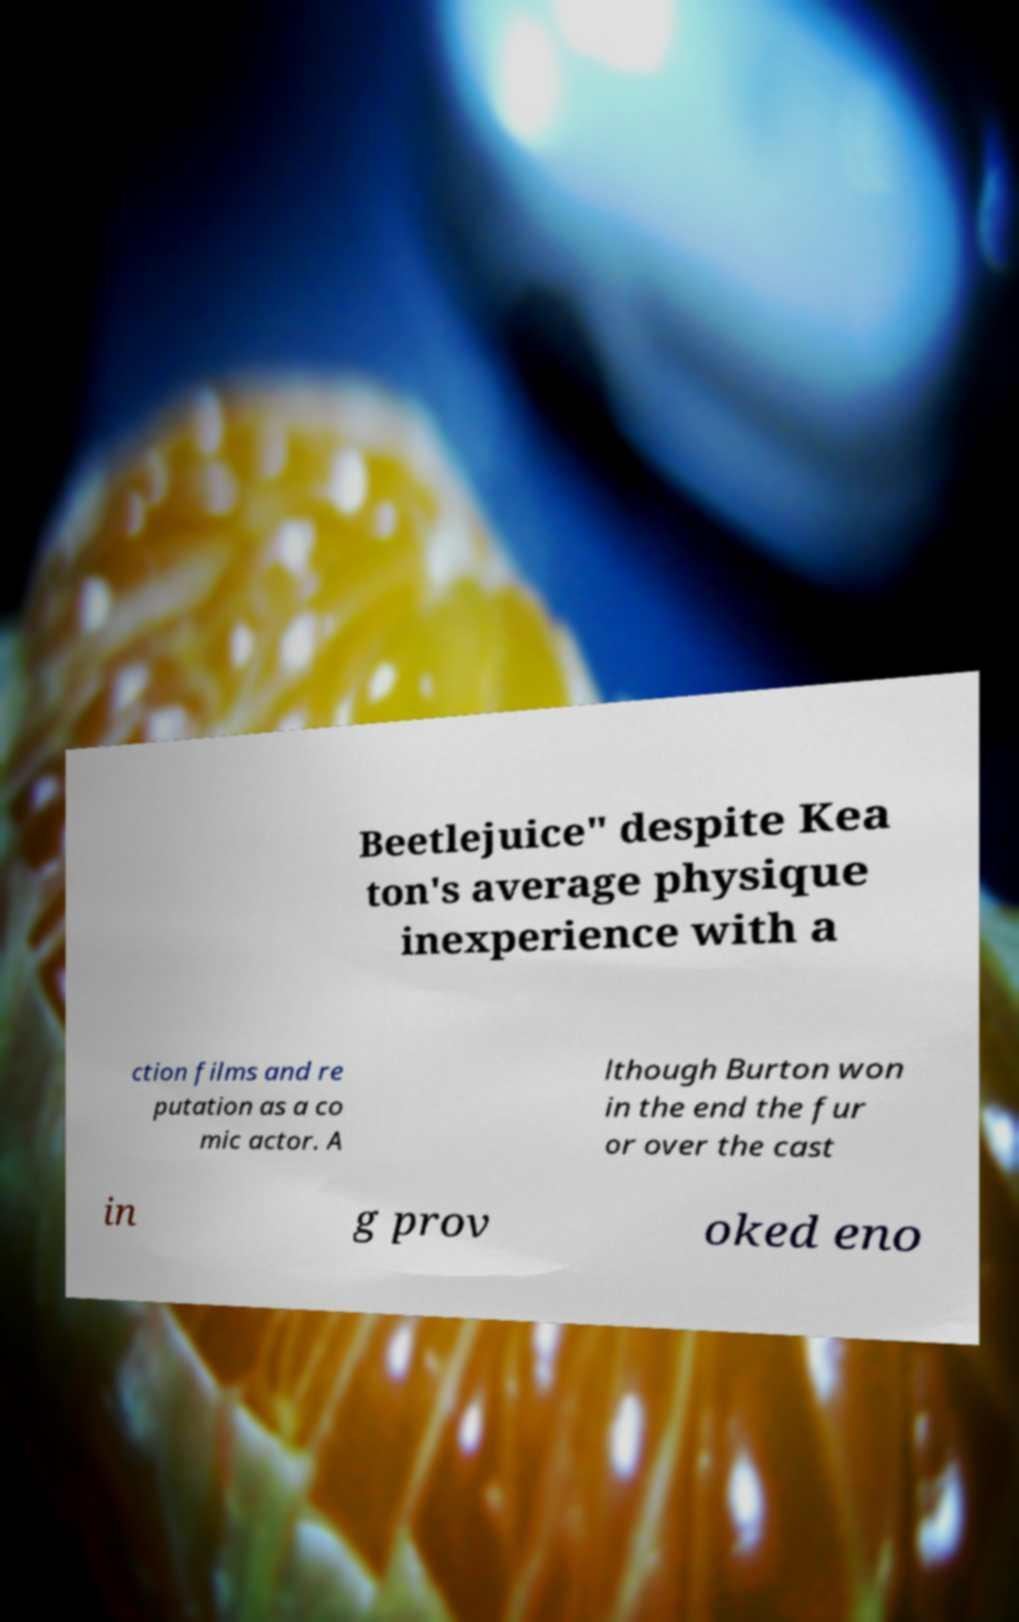Can you accurately transcribe the text from the provided image for me? Beetlejuice" despite Kea ton's average physique inexperience with a ction films and re putation as a co mic actor. A lthough Burton won in the end the fur or over the cast in g prov oked eno 